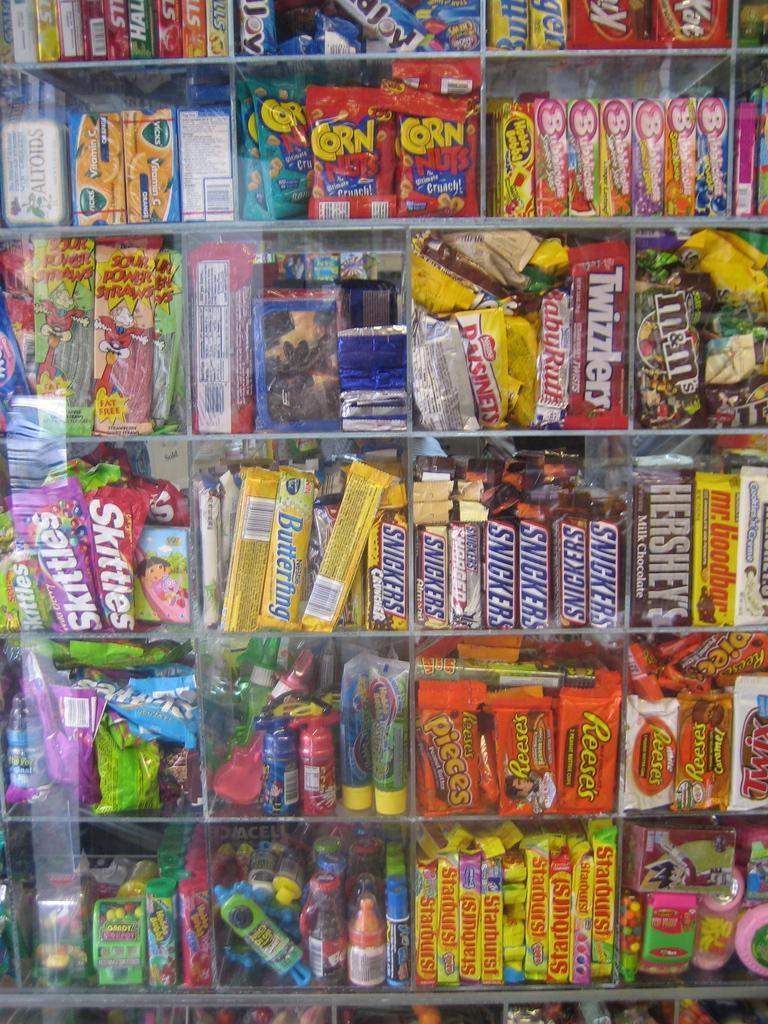<image>
Give a short and clear explanation of the subsequent image. A wall of colorful candy with halls cough drops in the top life corner next to the Almond Joy 